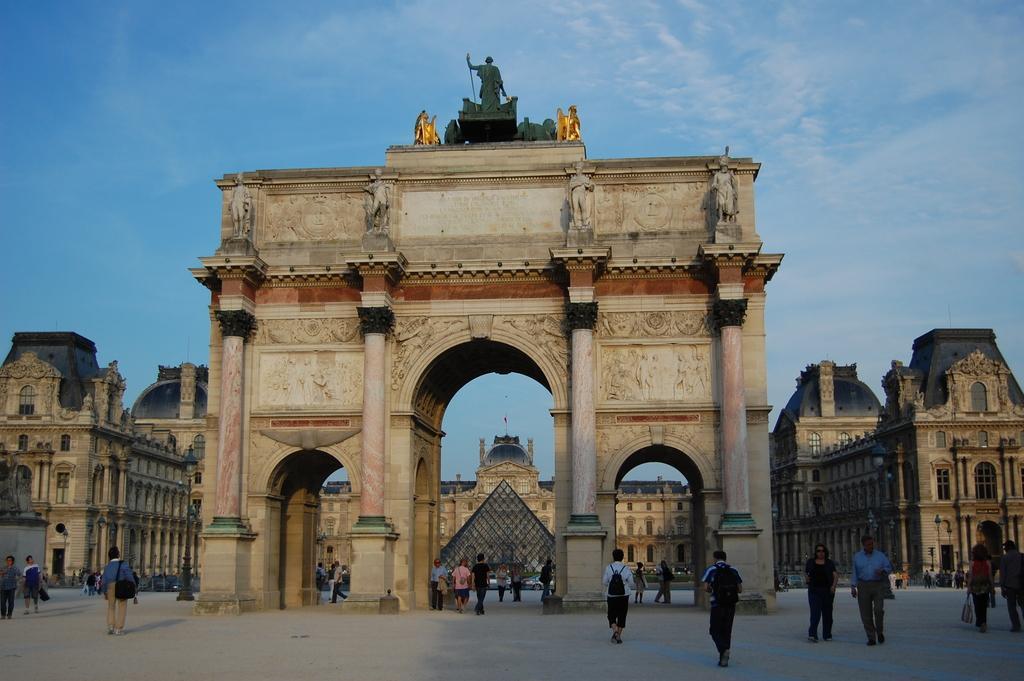Please provide a concise description of this image. In this picture I can see buildings and here I can see statues on the building. I can see people on the ground among them some carrying bags. In the background I can see the sky. 